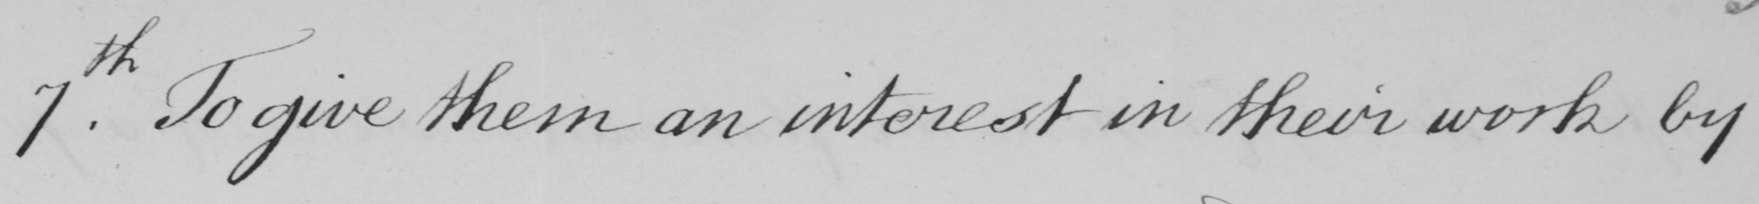What is written in this line of handwriting? 7th . To give them an interest in their work by 